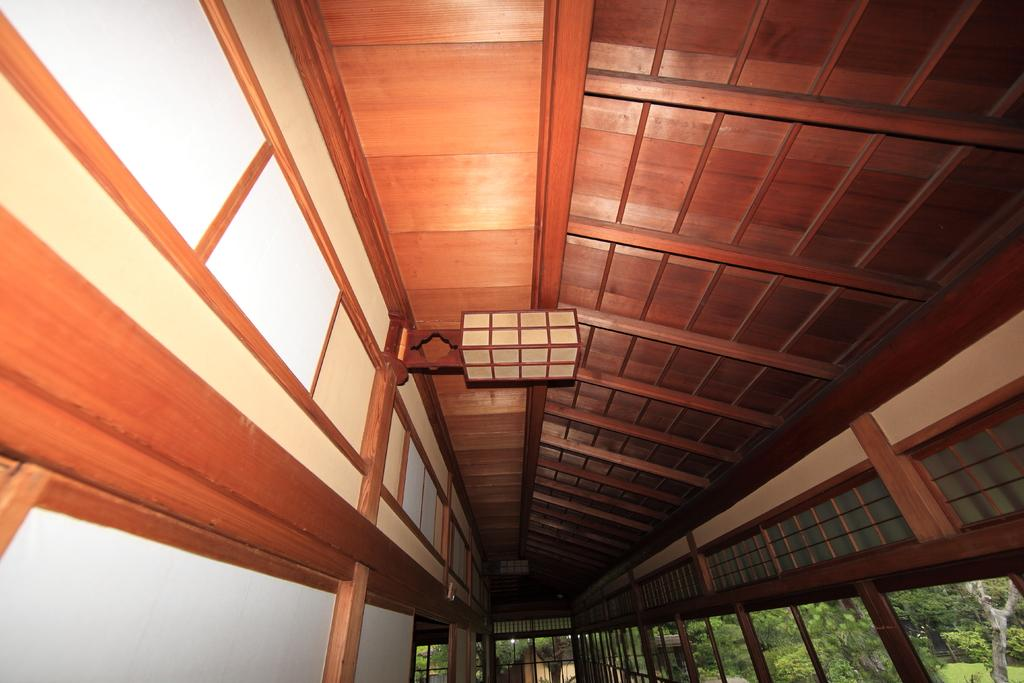What type of structure can be seen in the image? There is a wall and a roof in the image, which suggests a building or house. What material can be seen supporting the structure? There are wooden poles in the image, which are likely used as support for the roof or walls. What type of natural elements are present in the image? There are trees in the image, which indicates that the scene takes place outdoors or in a location with vegetation. Can you describe any objects present in the image? There are some objects in the image, but the specific nature of these objects is not mentioned in the facts provided. What type of pleasure can be seen enjoying the insect in the image? There is no mention of pleasure or insects in the image, so this question cannot be answered definitively. 